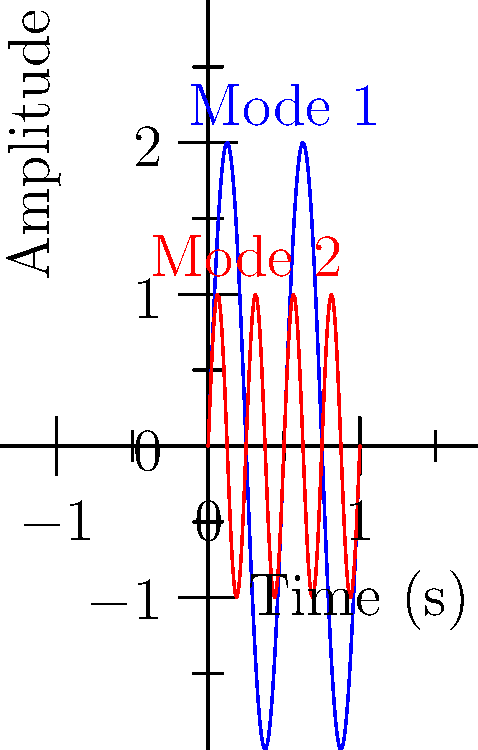A traditional drum used in folklore performances vibrates in different modes. The graph shows two vibration patterns: Mode 1 (blue) and Mode 2 (red). If the fundamental frequency of the drum is 100 Hz, what is the frequency of Mode 2? To solve this problem, we need to follow these steps:

1. Analyze the graph:
   - Mode 1 (blue) completes 2 full cycles in 1 second
   - Mode 2 (red) completes 4 full cycles in 1 second

2. Determine the relationship between the modes:
   - Mode 2 has twice the frequency of Mode 1

3. Calculate the frequency of Mode 1:
   - Given: The fundamental frequency (Mode 1) is 100 Hz

4. Calculate the frequency of Mode 2:
   - Since Mode 2 has twice the frequency of Mode 1:
   $f_{\text{Mode 2}} = 2 \times f_{\text{Mode 1}}$
   $f_{\text{Mode 2}} = 2 \times 100 \text{ Hz} = 200 \text{ Hz}$

Therefore, the frequency of Mode 2 is 200 Hz.
Answer: 200 Hz 